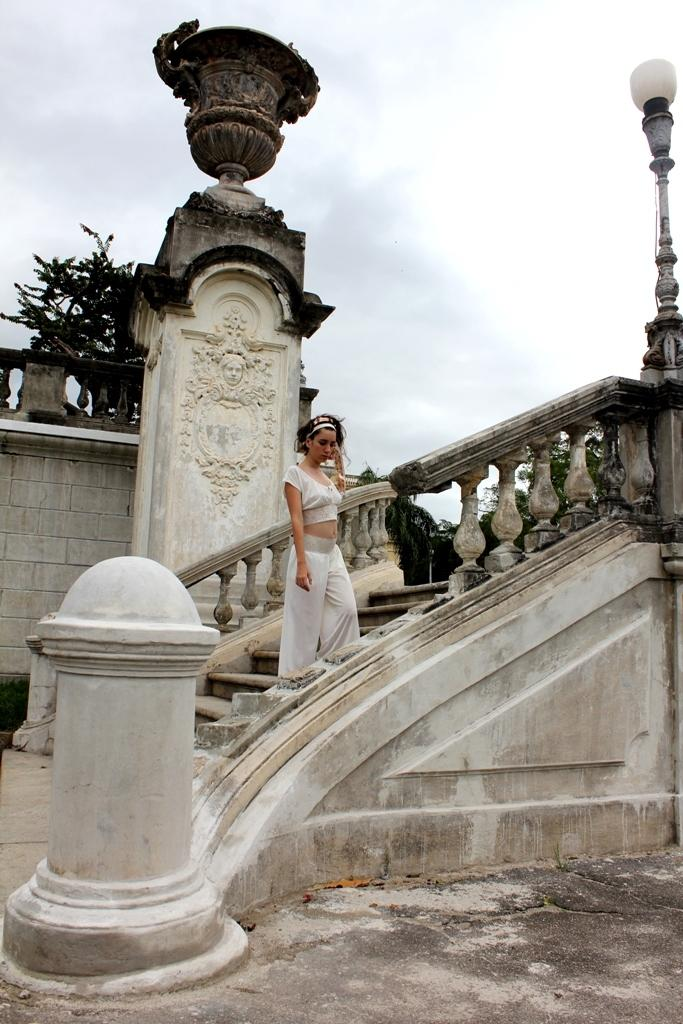Who is the main subject in the image? There is a woman in the image. What is the woman wearing? The woman is wearing a white dress. What objects are near the woman? There is a pole and a light beside the woman. What can be seen in the background of the image? There are trees and clouds in the background of the image. What type of education is the woman providing in the image? There is no indication in the image that the woman is providing any education, as the image does not show her teaching or interacting with students. 